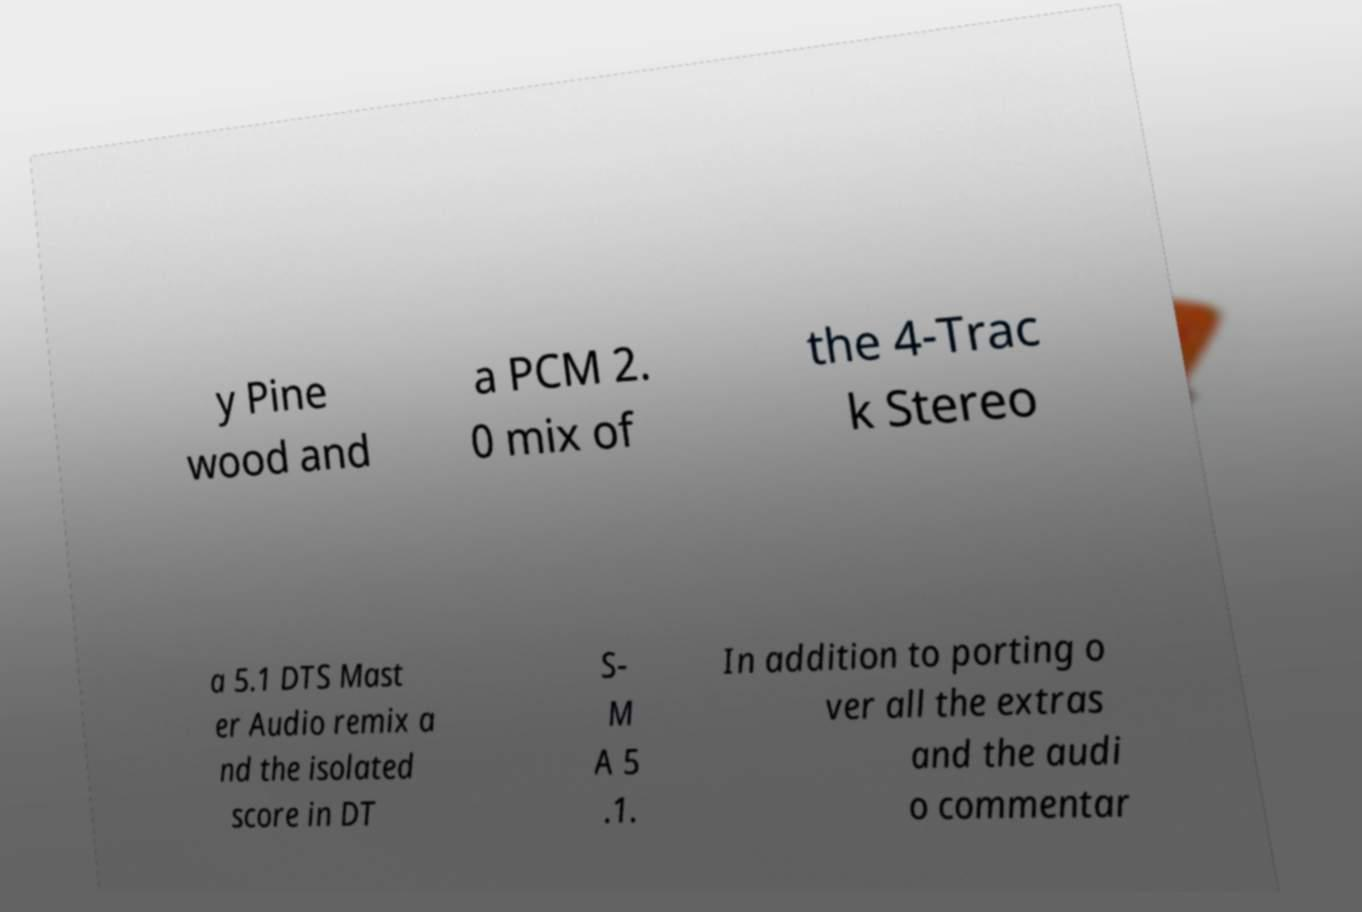Could you extract and type out the text from this image? y Pine wood and a PCM 2. 0 mix of the 4-Trac k Stereo a 5.1 DTS Mast er Audio remix a nd the isolated score in DT S- M A 5 .1. In addition to porting o ver all the extras and the audi o commentar 